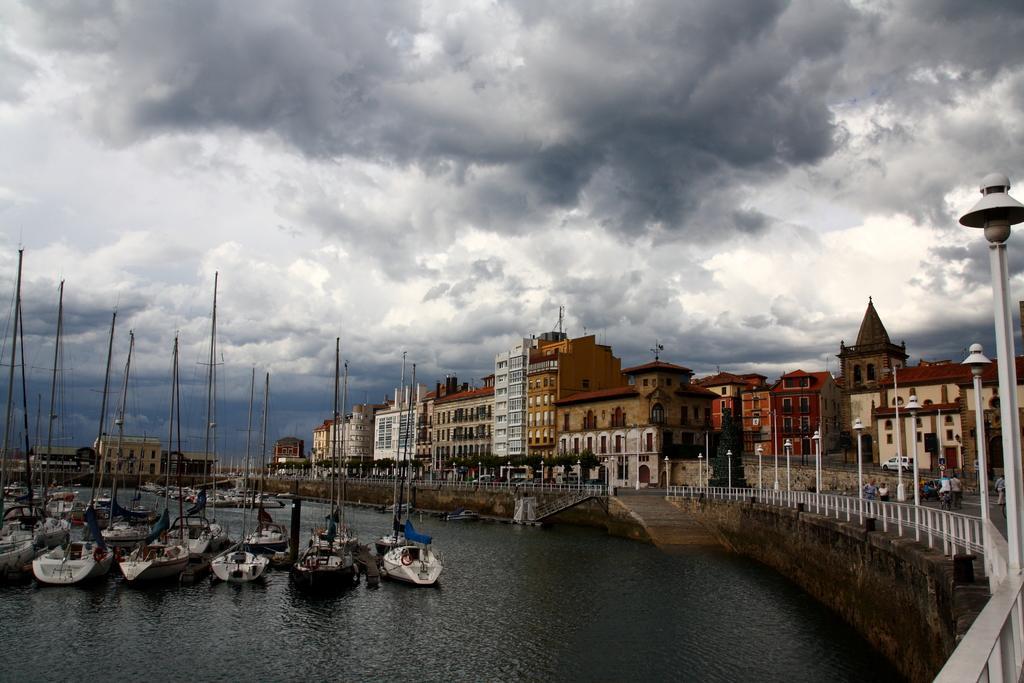Could you give a brief overview of what you see in this image? In this image, we can see buildings, poles, trees and there are people and vehicles on the road. At the top, there are clouds in the sky and at the bottom, there are boats on the water. 